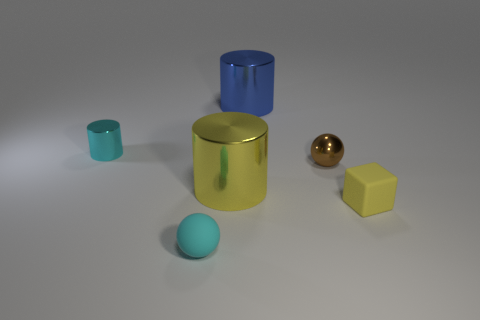Which objects in the image share the same color? The large cylinder and small cube share a similar shade of yellow. Color can significantly affect the perception of objects, highlighting similarities or differences among them. 